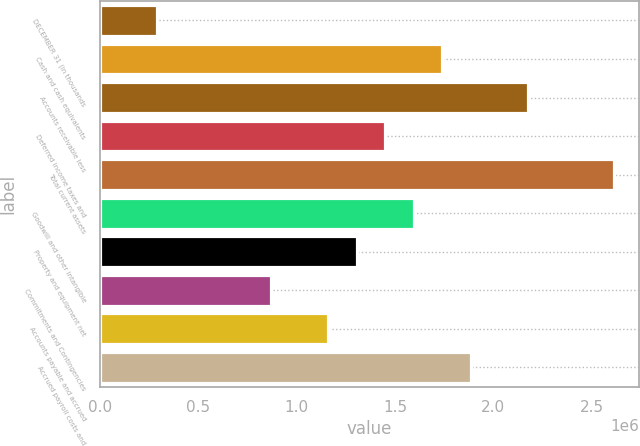Convert chart to OTSL. <chart><loc_0><loc_0><loc_500><loc_500><bar_chart><fcel>DECEMBER 31 (in thousands<fcel>Cash and cash equivalents<fcel>Accounts receivable less<fcel>Deferred income taxes and<fcel>Total current assets<fcel>Goodwill and other intangible<fcel>Property and equipment net<fcel>Commitments and Contingencies<fcel>Accounts payable and accrued<fcel>Accrued payroll costs and<nl><fcel>290186<fcel>1.74033e+06<fcel>2.17537e+06<fcel>1.4503e+06<fcel>2.61041e+06<fcel>1.59531e+06<fcel>1.30528e+06<fcel>870242<fcel>1.16027e+06<fcel>1.88534e+06<nl></chart> 